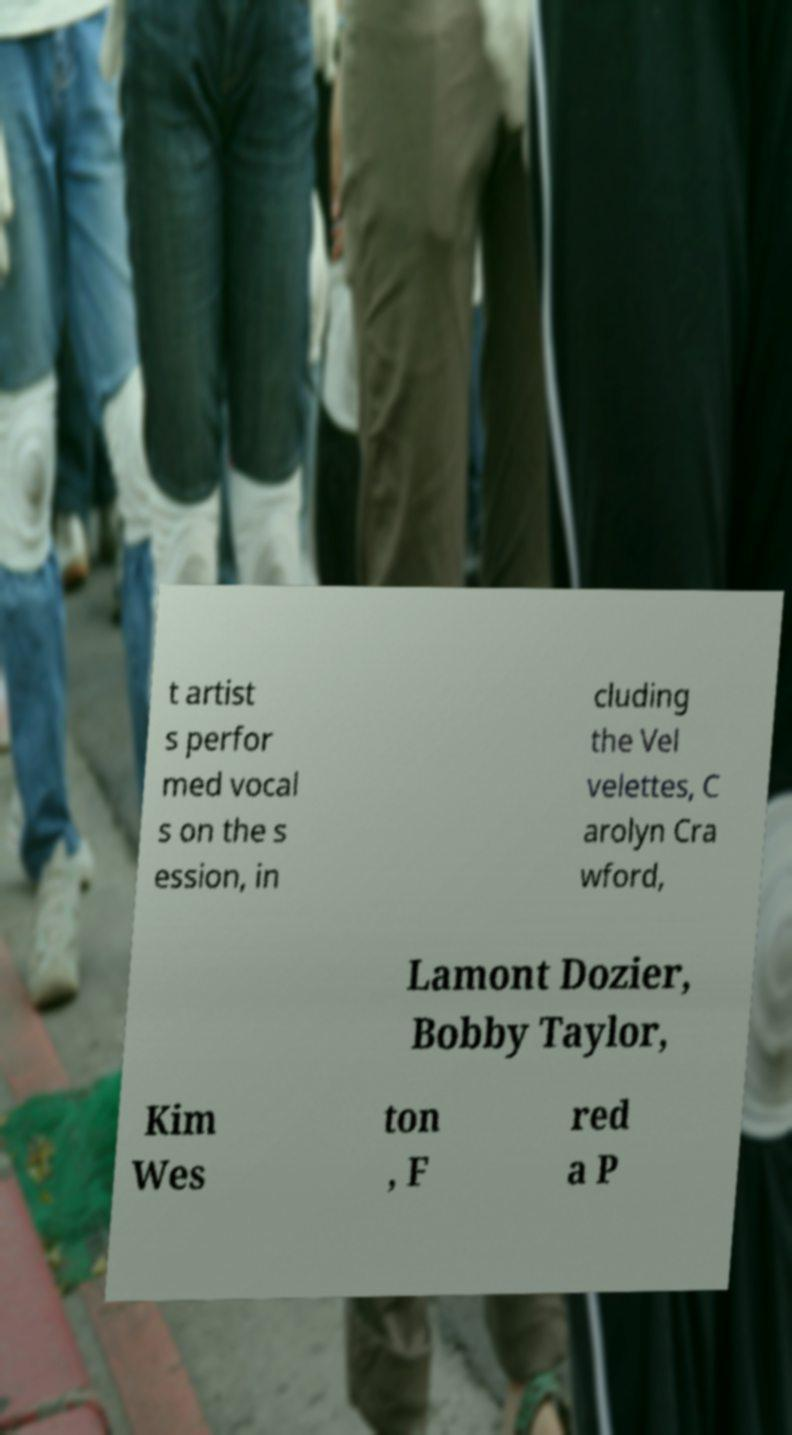Can you read and provide the text displayed in the image?This photo seems to have some interesting text. Can you extract and type it out for me? t artist s perfor med vocal s on the s ession, in cluding the Vel velettes, C arolyn Cra wford, Lamont Dozier, Bobby Taylor, Kim Wes ton , F red a P 